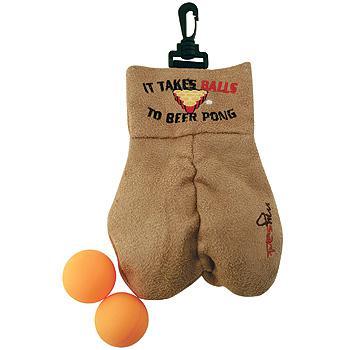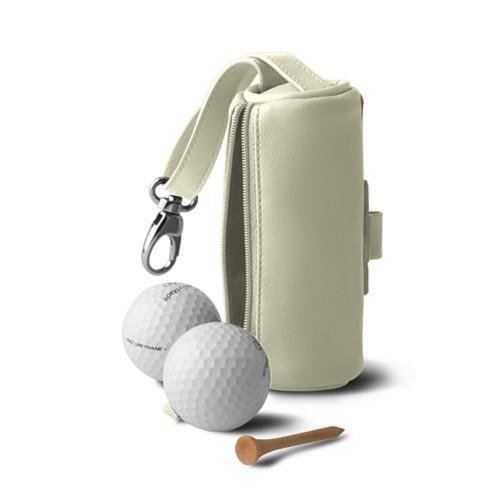The first image is the image on the left, the second image is the image on the right. Evaluate the accuracy of this statement regarding the images: "There are exactly 4 golf balls.". Is it true? Answer yes or no. Yes. The first image is the image on the left, the second image is the image on the right. For the images displayed, is the sentence "An image shows one brown sack next to a pair of balls." factually correct? Answer yes or no. Yes. 